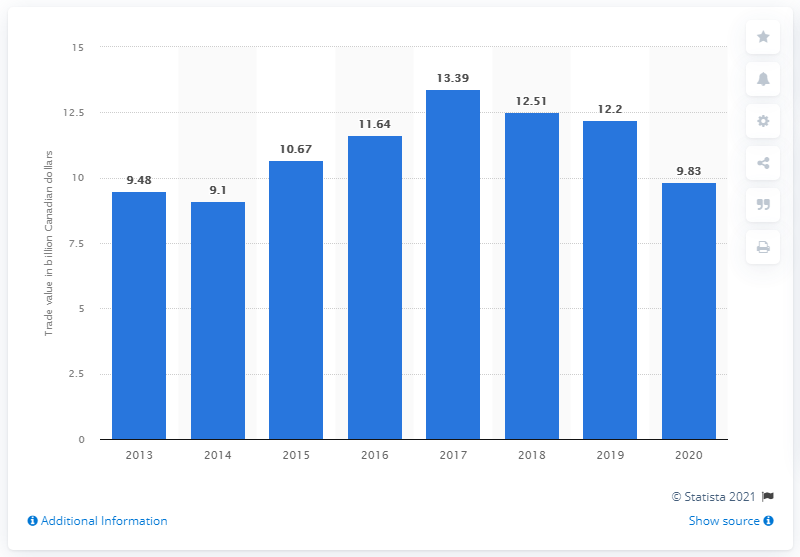Identify some key points in this picture. In 2010, the value of imports from Japan to Canada was $12.2 billion. In 2020, the value of imports from Japan to Canada was CAD 9.83 billion. 